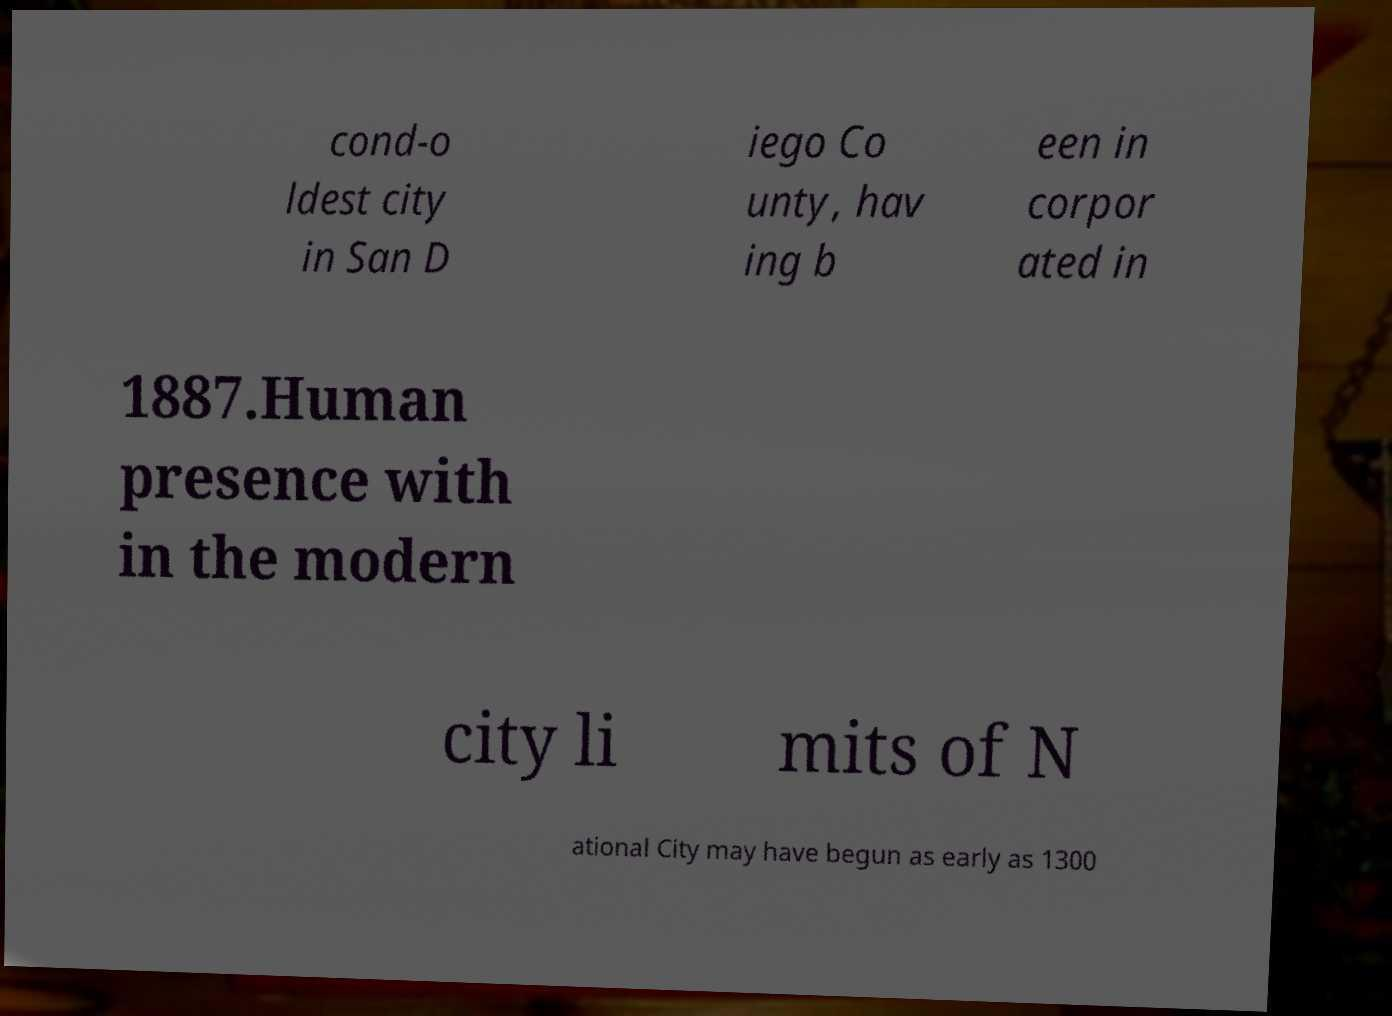Can you read and provide the text displayed in the image?This photo seems to have some interesting text. Can you extract and type it out for me? cond-o ldest city in San D iego Co unty, hav ing b een in corpor ated in 1887.Human presence with in the modern city li mits of N ational City may have begun as early as 1300 